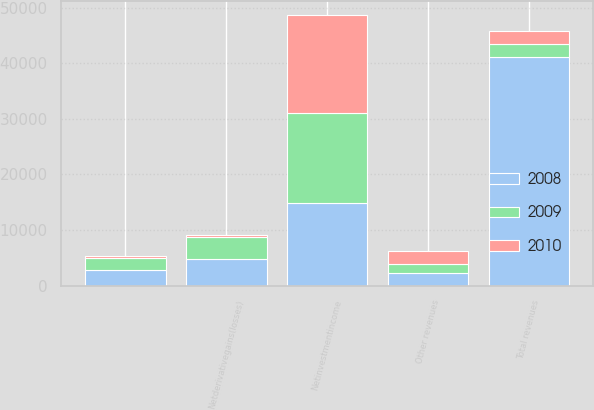Convert chart to OTSL. <chart><loc_0><loc_0><loc_500><loc_500><stacked_bar_chart><ecel><fcel>Unnamed: 1<fcel>Netinvestmentincome<fcel>Other revenues<fcel>Netderivativegains(losses)<fcel>Total revenues<nl><fcel>2010<fcel>392<fcel>17615<fcel>2328<fcel>265<fcel>2384<nl><fcel>2008<fcel>2906<fcel>14837<fcel>2329<fcel>4866<fcel>41057<nl><fcel>2009<fcel>2098<fcel>16289<fcel>1586<fcel>3910<fcel>2384<nl></chart> 